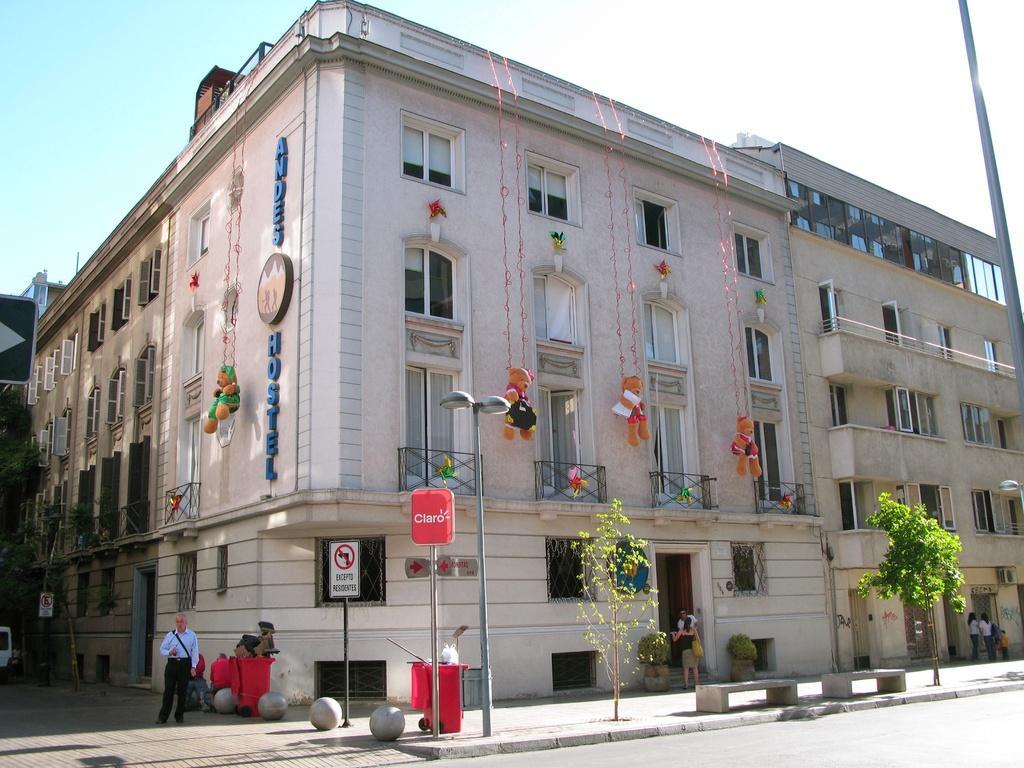Can you describe this image briefly? In this image in the center there is a building and at the bottom there is a footpath, trees and some persons are walking. And also there are some poles, lights, boards and some toys are hanging. At the top of the image there is sky. 